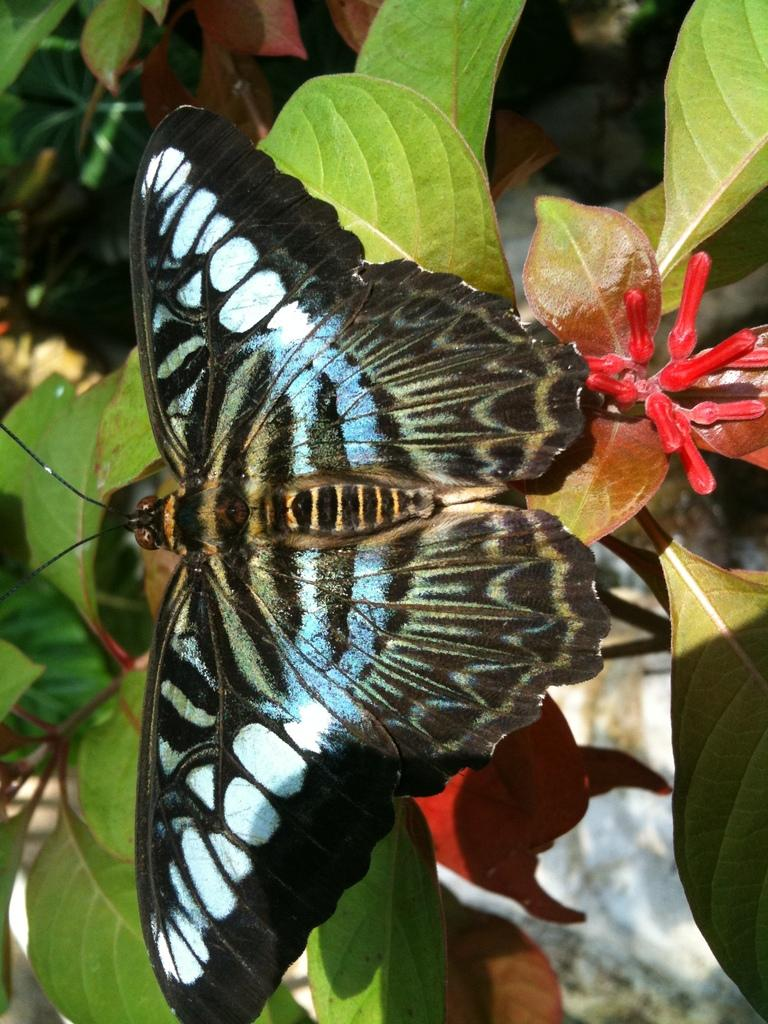What type of living organisms can be seen in the image? Plants and a butterfly are visible in the image. Can you describe the butterfly in the image? The butterfly is a winged insect with colorful patterns. What type of vase is the butterfly using to measure its wingspan in the image? There is no vase or measurement of wingspan depicted in the image; it simply shows a butterfly near plants. 